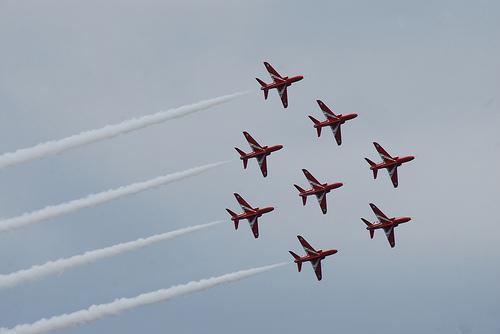How many planes are there?
Give a very brief answer. 8. 